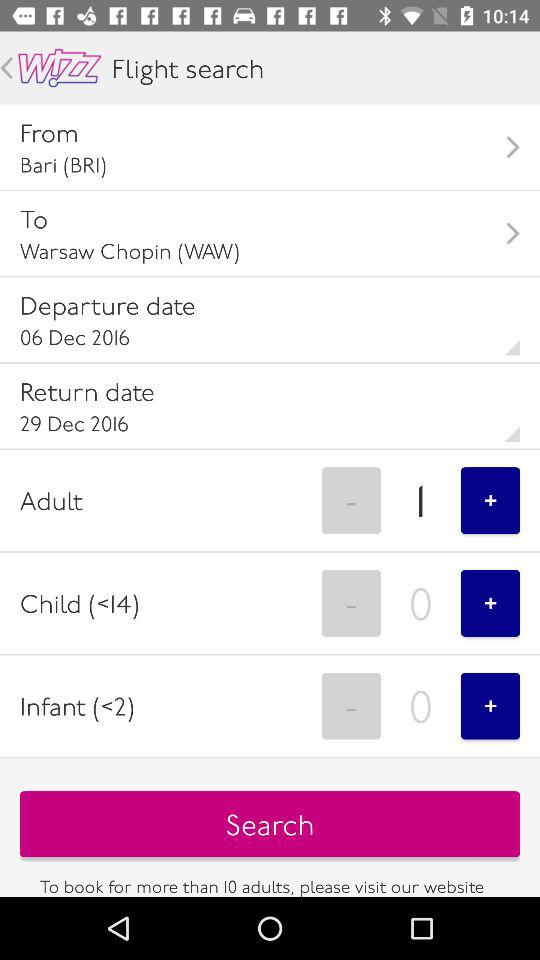What is the return date of the flight? The return date of the flight is December 26, 2016. 